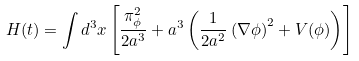Convert formula to latex. <formula><loc_0><loc_0><loc_500><loc_500>H ( t ) = \int d ^ { 3 } { x } \left [ \frac { \pi _ { \phi } ^ { 2 } } { 2 a ^ { 3 } } + a ^ { 3 } \left ( \frac { 1 } { 2 a ^ { 2 } } \left ( \nabla \phi \right ) ^ { 2 } + V ( \phi ) \right ) \right ]</formula> 